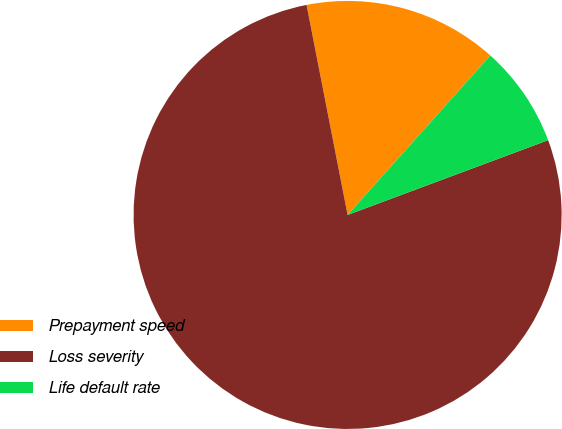Convert chart to OTSL. <chart><loc_0><loc_0><loc_500><loc_500><pie_chart><fcel>Prepayment speed<fcel>Loss severity<fcel>Life default rate<nl><fcel>14.69%<fcel>77.61%<fcel>7.7%<nl></chart> 